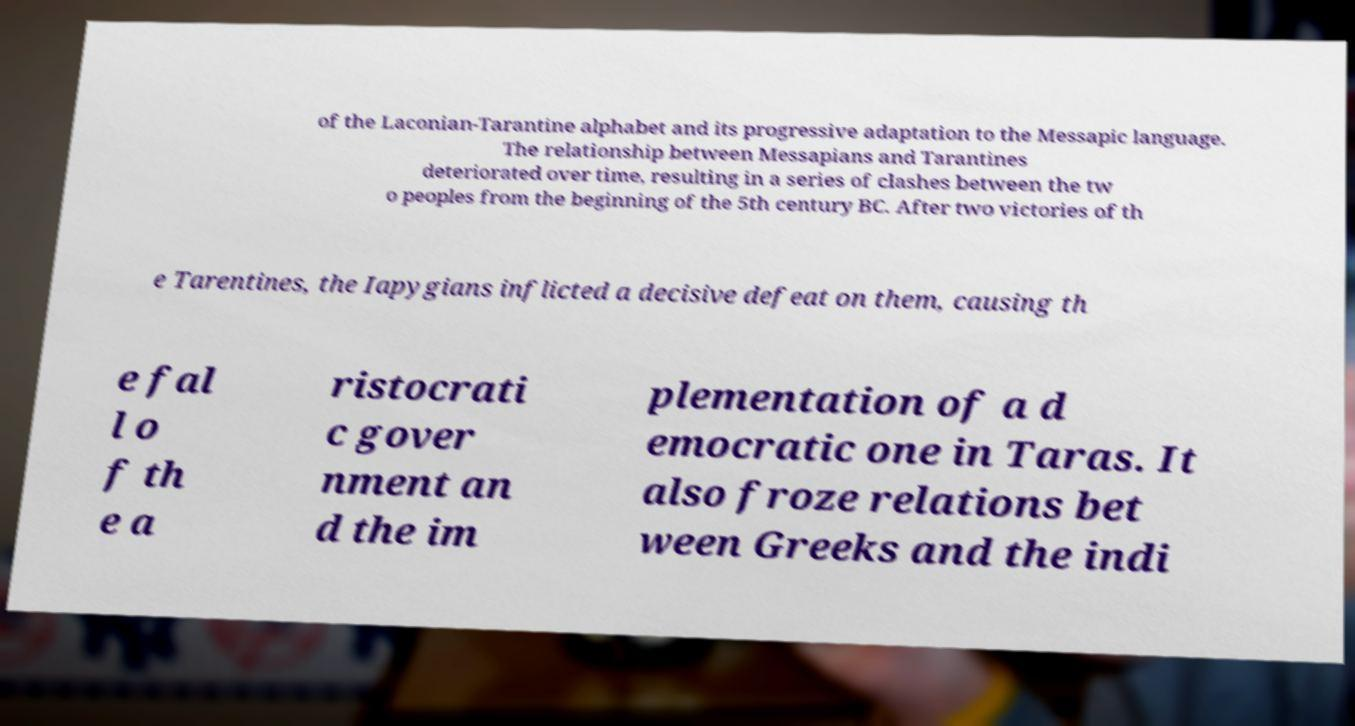For documentation purposes, I need the text within this image transcribed. Could you provide that? of the Laconian-Tarantine alphabet and its progressive adaptation to the Messapic language. The relationship between Messapians and Tarantines deteriorated over time, resulting in a series of clashes between the tw o peoples from the beginning of the 5th century BC. After two victories of th e Tarentines, the Iapygians inflicted a decisive defeat on them, causing th e fal l o f th e a ristocrati c gover nment an d the im plementation of a d emocratic one in Taras. It also froze relations bet ween Greeks and the indi 